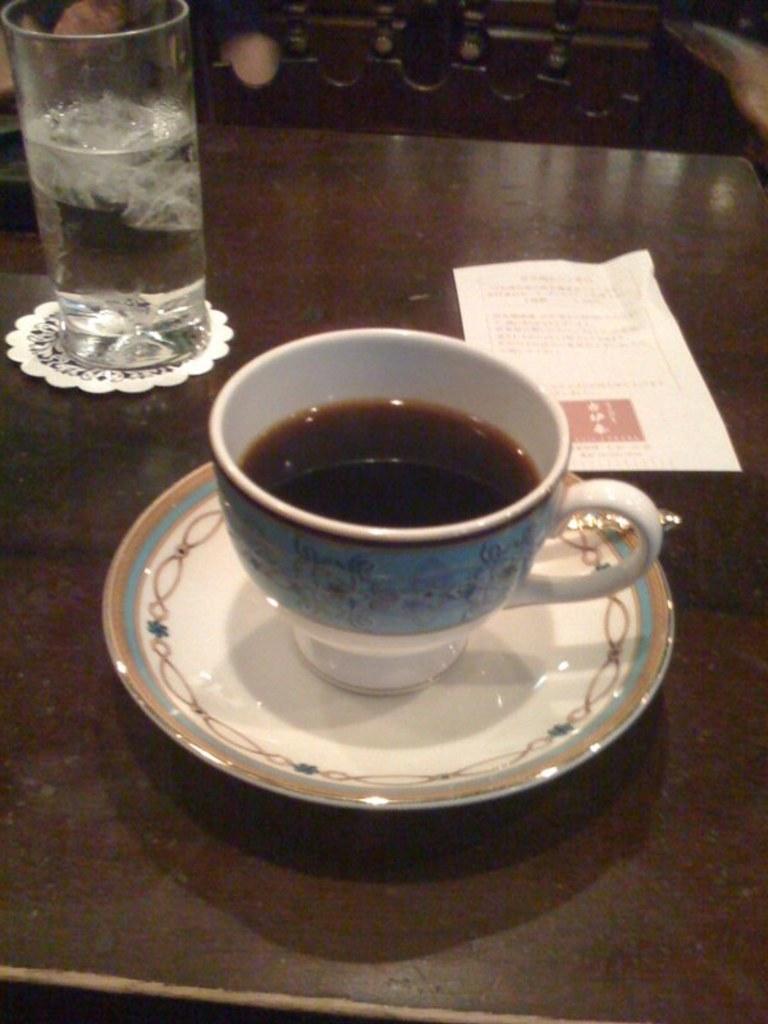Could you give a brief overview of what you see in this image? In this image we can see a cup with liquid, saucer, paper and other objects on the surface. In the background of the image there are wooden objects. 